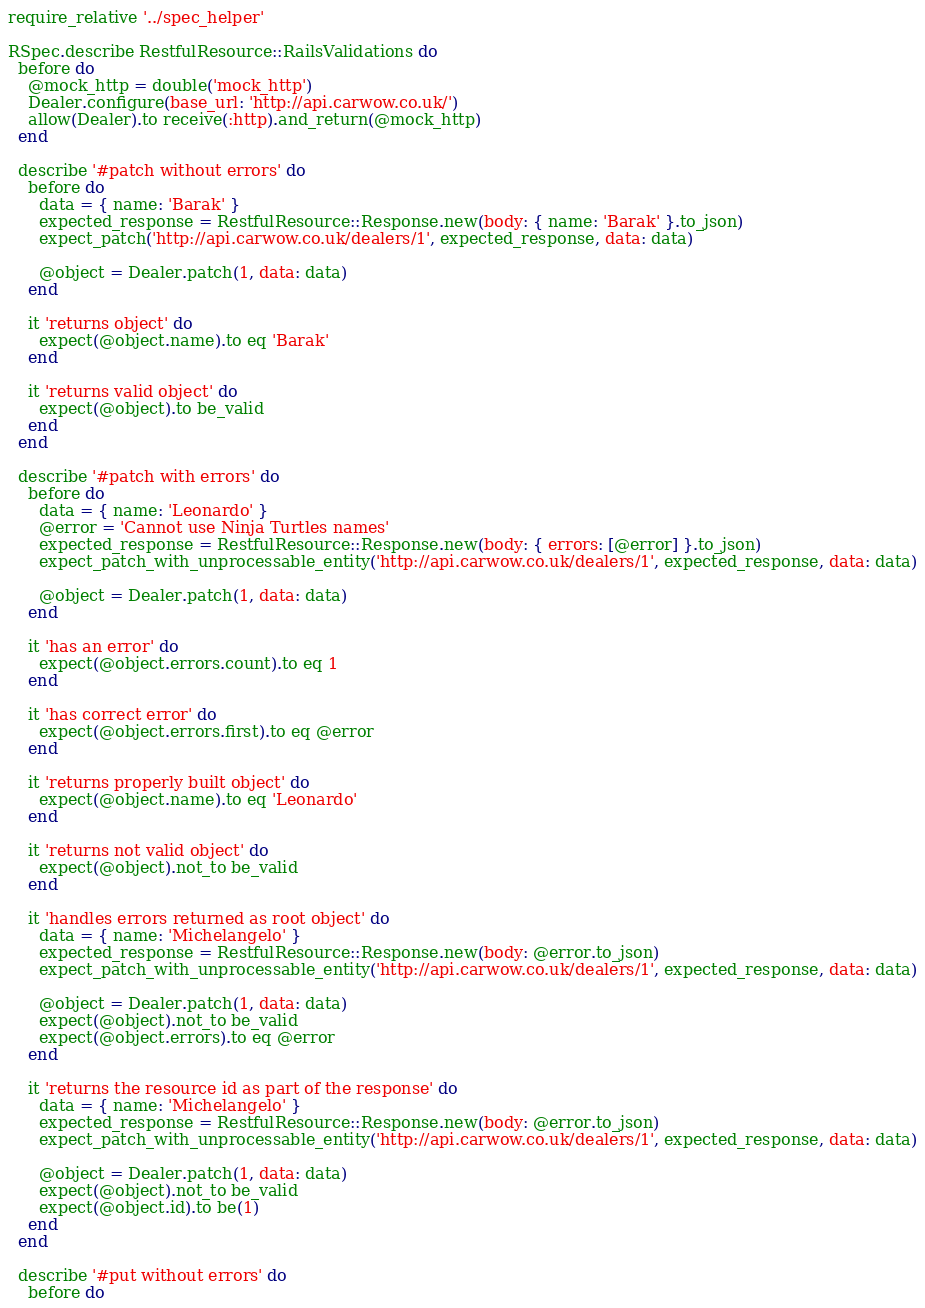<code> <loc_0><loc_0><loc_500><loc_500><_Ruby_>require_relative '../spec_helper'

RSpec.describe RestfulResource::RailsValidations do
  before do
    @mock_http = double('mock_http')
    Dealer.configure(base_url: 'http://api.carwow.co.uk/')
    allow(Dealer).to receive(:http).and_return(@mock_http)
  end

  describe '#patch without errors' do
    before do
      data = { name: 'Barak' }
      expected_response = RestfulResource::Response.new(body: { name: 'Barak' }.to_json)
      expect_patch('http://api.carwow.co.uk/dealers/1', expected_response, data: data)

      @object = Dealer.patch(1, data: data)
    end

    it 'returns object' do
      expect(@object.name).to eq 'Barak'
    end

    it 'returns valid object' do
      expect(@object).to be_valid
    end
  end

  describe '#patch with errors' do
    before do
      data = { name: 'Leonardo' }
      @error = 'Cannot use Ninja Turtles names'
      expected_response = RestfulResource::Response.new(body: { errors: [@error] }.to_json)
      expect_patch_with_unprocessable_entity('http://api.carwow.co.uk/dealers/1', expected_response, data: data)

      @object = Dealer.patch(1, data: data)
    end

    it 'has an error' do
      expect(@object.errors.count).to eq 1
    end

    it 'has correct error' do
      expect(@object.errors.first).to eq @error
    end

    it 'returns properly built object' do
      expect(@object.name).to eq 'Leonardo'
    end

    it 'returns not valid object' do
      expect(@object).not_to be_valid
    end

    it 'handles errors returned as root object' do
      data = { name: 'Michelangelo' }
      expected_response = RestfulResource::Response.new(body: @error.to_json)
      expect_patch_with_unprocessable_entity('http://api.carwow.co.uk/dealers/1', expected_response, data: data)

      @object = Dealer.patch(1, data: data)
      expect(@object).not_to be_valid
      expect(@object.errors).to eq @error
    end

    it 'returns the resource id as part of the response' do
      data = { name: 'Michelangelo' }
      expected_response = RestfulResource::Response.new(body: @error.to_json)
      expect_patch_with_unprocessable_entity('http://api.carwow.co.uk/dealers/1', expected_response, data: data)

      @object = Dealer.patch(1, data: data)
      expect(@object).not_to be_valid
      expect(@object.id).to be(1)
    end
  end

  describe '#put without errors' do
    before do</code> 